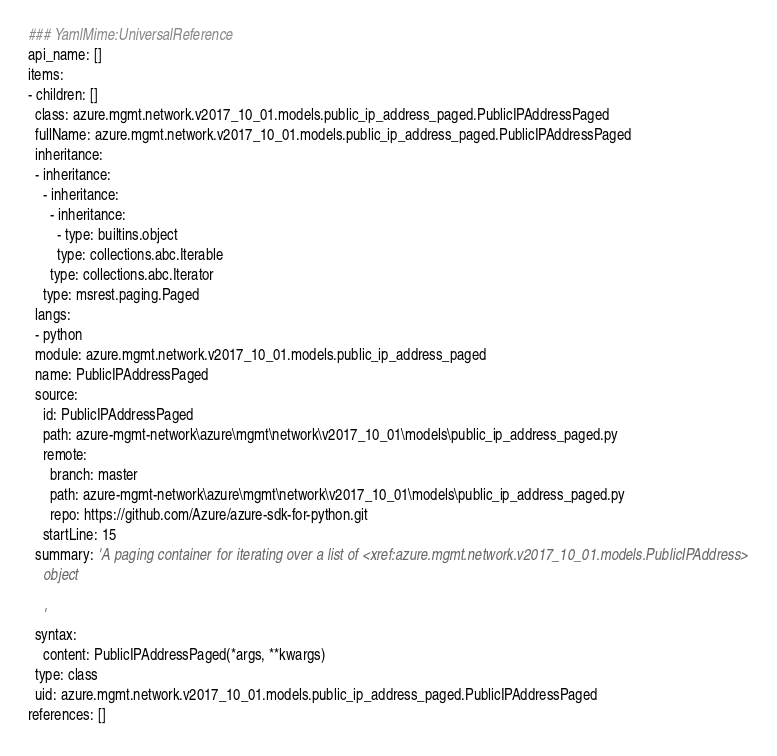Convert code to text. <code><loc_0><loc_0><loc_500><loc_500><_YAML_>### YamlMime:UniversalReference
api_name: []
items:
- children: []
  class: azure.mgmt.network.v2017_10_01.models.public_ip_address_paged.PublicIPAddressPaged
  fullName: azure.mgmt.network.v2017_10_01.models.public_ip_address_paged.PublicIPAddressPaged
  inheritance:
  - inheritance:
    - inheritance:
      - inheritance:
        - type: builtins.object
        type: collections.abc.Iterable
      type: collections.abc.Iterator
    type: msrest.paging.Paged
  langs:
  - python
  module: azure.mgmt.network.v2017_10_01.models.public_ip_address_paged
  name: PublicIPAddressPaged
  source:
    id: PublicIPAddressPaged
    path: azure-mgmt-network\azure\mgmt\network\v2017_10_01\models\public_ip_address_paged.py
    remote:
      branch: master
      path: azure-mgmt-network\azure\mgmt\network\v2017_10_01\models\public_ip_address_paged.py
      repo: https://github.com/Azure/azure-sdk-for-python.git
    startLine: 15
  summary: 'A paging container for iterating over a list of <xref:azure.mgmt.network.v2017_10_01.models.PublicIPAddress>
    object

    '
  syntax:
    content: PublicIPAddressPaged(*args, **kwargs)
  type: class
  uid: azure.mgmt.network.v2017_10_01.models.public_ip_address_paged.PublicIPAddressPaged
references: []
</code> 